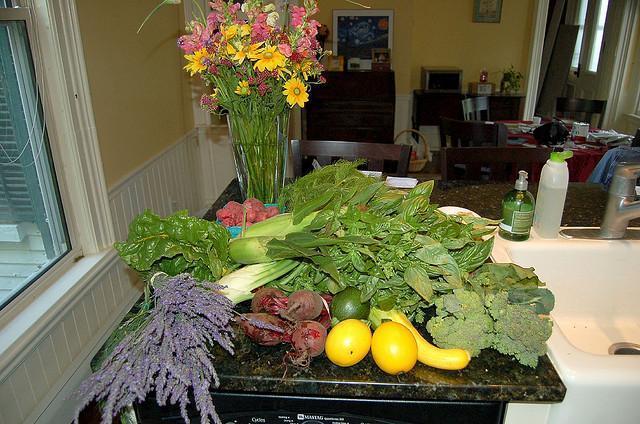How many chairs are visible?
Give a very brief answer. 2. 